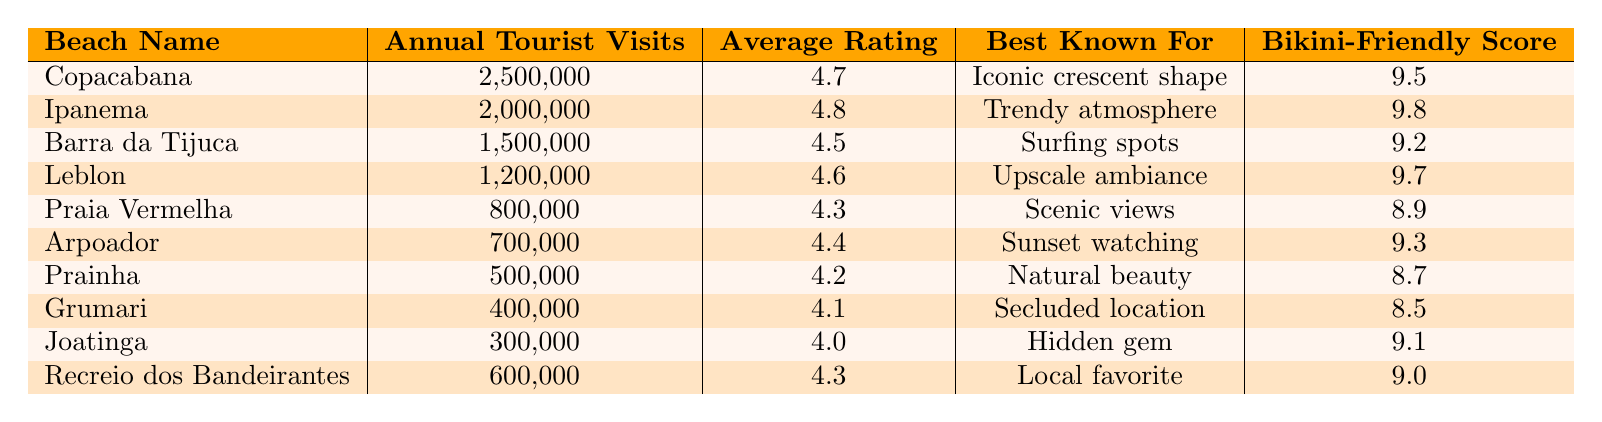What is the beach with the highest annual tourist visits? From the table, Copacabana has the highest annual tourist visits, with 2,500,000 recorded visits.
Answer: Copacabana Which beach has the best average rating? Ipanema has the best average rating of 4.8, which is higher than that of all other beaches listed in the table.
Answer: Ipanema How many total annual tourist visits are there at the top three beaches? By adding the annual tourist visits for Copacabana (2,500,000), Ipanema (2,000,000), and Barra da Tijuca (1,500,000), the total is 2,500,000 + 2,000,000 + 1,500,000 = 6,000,000.
Answer: 6,000,000 Is Leblon known for its surfing spots? The table indicates that Leblon is known for its upscale ambiance, not for surfing spots, which are specifically associated with Barra da Tijuca.
Answer: No Which beach has a Bikini-Friendly Score of 9.0? Looking at the table, Recreio dos Bandeirantes has a Bikini-Friendly Score of 9.0.
Answer: Recreio dos Bandeirantes What is the difference in annual tourist visits between Copacabana and the least visited beach? Copacabana has 2,500,000 visits, and the least visited beach, Grumari, has 400,000 visits. The difference is 2,500,000 - 400,000 = 2,100,000.
Answer: 2,100,000 What is the average Bikini-Friendly Score of the beaches listed? To find the average, add the Bikini-Friendly Scores: (9.5 + 9.8 + 9.2 + 9.7 + 8.9 + 9.3 + 8.7 + 8.5 + 9.1 + 9.0) = 97.7, then divide by the number of beaches (10): 97.7 / 10 = 9.77.
Answer: 9.77 Which beach is best known for sunset watching? According to the table, Arpoador is best known for sunset watching.
Answer: Arpoador What is the average annual tourist visits for the beaches with a Bikini-Friendly Score above 9.0? The eligible beaches are Copacabana (2,500,000), Ipanema (2,000,000), Leblon (1,200,000), Arpoador (700,000), Recreio dos Bandeirantes (600,000), and Joatinga (300,000). Totaling those visits gives 2,500,000 + 2,000,000 + 1,200,000 + 700,000 + 600,000 + 300,000 = 7,300,000, and dividing by 6 gives an average of 1,216,667.
Answer: 1,216,667 Is there a beach that has a lower Average Rating than Praia Vermelha? Praia Vermelha has an average rating of 4.3, and the only beach with a lower rating is Grumari with 4.1. Therefore, yes, there is a beach with a lower rating.
Answer: Yes 